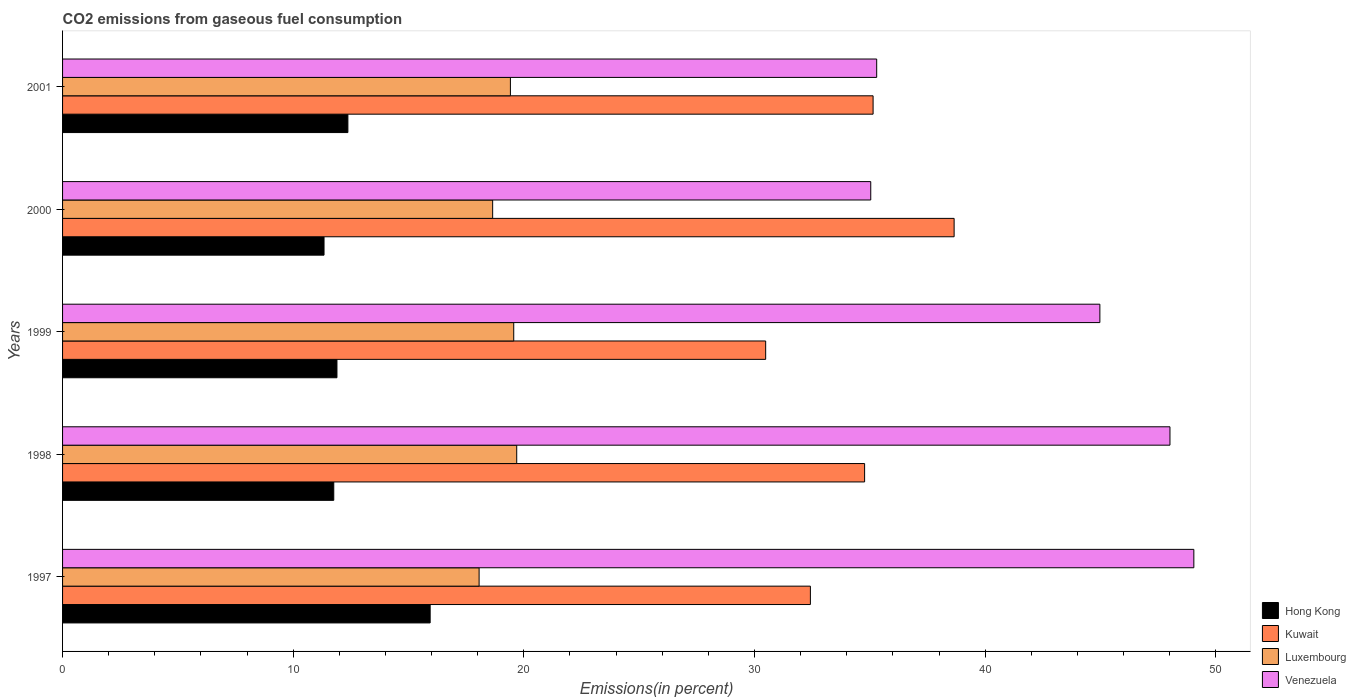What is the label of the 2nd group of bars from the top?
Offer a terse response. 2000. What is the total CO2 emitted in Kuwait in 1999?
Ensure brevity in your answer.  30.48. Across all years, what is the maximum total CO2 emitted in Luxembourg?
Make the answer very short. 19.69. Across all years, what is the minimum total CO2 emitted in Kuwait?
Your answer should be very brief. 30.48. What is the total total CO2 emitted in Venezuela in the graph?
Provide a short and direct response. 212.38. What is the difference between the total CO2 emitted in Venezuela in 1997 and that in 1998?
Your answer should be compact. 1.04. What is the difference between the total CO2 emitted in Venezuela in 2001 and the total CO2 emitted in Kuwait in 1999?
Your answer should be very brief. 4.81. What is the average total CO2 emitted in Kuwait per year?
Ensure brevity in your answer.  34.3. In the year 2000, what is the difference between the total CO2 emitted in Venezuela and total CO2 emitted in Kuwait?
Keep it short and to the point. -3.61. What is the ratio of the total CO2 emitted in Kuwait in 1997 to that in 2000?
Your answer should be compact. 0.84. What is the difference between the highest and the second highest total CO2 emitted in Venezuela?
Your response must be concise. 1.04. What is the difference between the highest and the lowest total CO2 emitted in Kuwait?
Give a very brief answer. 8.17. In how many years, is the total CO2 emitted in Hong Kong greater than the average total CO2 emitted in Hong Kong taken over all years?
Provide a short and direct response. 1. What does the 1st bar from the top in 2001 represents?
Keep it short and to the point. Venezuela. What does the 1st bar from the bottom in 1997 represents?
Your answer should be very brief. Hong Kong. How many bars are there?
Your answer should be compact. 20. What is the difference between two consecutive major ticks on the X-axis?
Make the answer very short. 10. Does the graph contain any zero values?
Give a very brief answer. No. Where does the legend appear in the graph?
Make the answer very short. Bottom right. How are the legend labels stacked?
Your answer should be compact. Vertical. What is the title of the graph?
Keep it short and to the point. CO2 emissions from gaseous fuel consumption. What is the label or title of the X-axis?
Your response must be concise. Emissions(in percent). What is the Emissions(in percent) in Hong Kong in 1997?
Offer a terse response. 15.94. What is the Emissions(in percent) of Kuwait in 1997?
Ensure brevity in your answer.  32.42. What is the Emissions(in percent) of Luxembourg in 1997?
Keep it short and to the point. 18.06. What is the Emissions(in percent) in Venezuela in 1997?
Offer a very short reply. 49.05. What is the Emissions(in percent) of Hong Kong in 1998?
Ensure brevity in your answer.  11.76. What is the Emissions(in percent) of Kuwait in 1998?
Make the answer very short. 34.77. What is the Emissions(in percent) in Luxembourg in 1998?
Provide a short and direct response. 19.69. What is the Emissions(in percent) of Venezuela in 1998?
Your response must be concise. 48.01. What is the Emissions(in percent) in Hong Kong in 1999?
Offer a very short reply. 11.9. What is the Emissions(in percent) in Kuwait in 1999?
Your answer should be compact. 30.48. What is the Emissions(in percent) of Luxembourg in 1999?
Ensure brevity in your answer.  19.56. What is the Emissions(in percent) in Venezuela in 1999?
Make the answer very short. 44.97. What is the Emissions(in percent) in Hong Kong in 2000?
Your answer should be compact. 11.34. What is the Emissions(in percent) of Kuwait in 2000?
Provide a succinct answer. 38.66. What is the Emissions(in percent) of Luxembourg in 2000?
Offer a terse response. 18.65. What is the Emissions(in percent) in Venezuela in 2000?
Ensure brevity in your answer.  35.04. What is the Emissions(in percent) in Hong Kong in 2001?
Offer a terse response. 12.37. What is the Emissions(in percent) of Kuwait in 2001?
Ensure brevity in your answer.  35.14. What is the Emissions(in percent) in Luxembourg in 2001?
Ensure brevity in your answer.  19.42. What is the Emissions(in percent) in Venezuela in 2001?
Your answer should be compact. 35.3. Across all years, what is the maximum Emissions(in percent) in Hong Kong?
Your answer should be compact. 15.94. Across all years, what is the maximum Emissions(in percent) in Kuwait?
Your response must be concise. 38.66. Across all years, what is the maximum Emissions(in percent) in Luxembourg?
Offer a very short reply. 19.69. Across all years, what is the maximum Emissions(in percent) in Venezuela?
Offer a terse response. 49.05. Across all years, what is the minimum Emissions(in percent) of Hong Kong?
Offer a terse response. 11.34. Across all years, what is the minimum Emissions(in percent) in Kuwait?
Make the answer very short. 30.48. Across all years, what is the minimum Emissions(in percent) in Luxembourg?
Provide a short and direct response. 18.06. Across all years, what is the minimum Emissions(in percent) in Venezuela?
Your response must be concise. 35.04. What is the total Emissions(in percent) in Hong Kong in the graph?
Your answer should be very brief. 63.3. What is the total Emissions(in percent) in Kuwait in the graph?
Make the answer very short. 171.48. What is the total Emissions(in percent) of Luxembourg in the graph?
Provide a short and direct response. 95.38. What is the total Emissions(in percent) of Venezuela in the graph?
Give a very brief answer. 212.38. What is the difference between the Emissions(in percent) in Hong Kong in 1997 and that in 1998?
Your answer should be compact. 4.18. What is the difference between the Emissions(in percent) of Kuwait in 1997 and that in 1998?
Ensure brevity in your answer.  -2.35. What is the difference between the Emissions(in percent) of Luxembourg in 1997 and that in 1998?
Ensure brevity in your answer.  -1.63. What is the difference between the Emissions(in percent) of Venezuela in 1997 and that in 1998?
Your response must be concise. 1.04. What is the difference between the Emissions(in percent) of Hong Kong in 1997 and that in 1999?
Provide a short and direct response. 4.04. What is the difference between the Emissions(in percent) of Kuwait in 1997 and that in 1999?
Give a very brief answer. 1.94. What is the difference between the Emissions(in percent) of Luxembourg in 1997 and that in 1999?
Keep it short and to the point. -1.5. What is the difference between the Emissions(in percent) of Venezuela in 1997 and that in 1999?
Keep it short and to the point. 4.07. What is the difference between the Emissions(in percent) in Hong Kong in 1997 and that in 2000?
Offer a very short reply. 4.6. What is the difference between the Emissions(in percent) of Kuwait in 1997 and that in 2000?
Ensure brevity in your answer.  -6.23. What is the difference between the Emissions(in percent) of Luxembourg in 1997 and that in 2000?
Provide a short and direct response. -0.59. What is the difference between the Emissions(in percent) in Venezuela in 1997 and that in 2000?
Give a very brief answer. 14.01. What is the difference between the Emissions(in percent) in Hong Kong in 1997 and that in 2001?
Provide a short and direct response. 3.57. What is the difference between the Emissions(in percent) in Kuwait in 1997 and that in 2001?
Ensure brevity in your answer.  -2.72. What is the difference between the Emissions(in percent) in Luxembourg in 1997 and that in 2001?
Your answer should be compact. -1.36. What is the difference between the Emissions(in percent) in Venezuela in 1997 and that in 2001?
Provide a short and direct response. 13.75. What is the difference between the Emissions(in percent) of Hong Kong in 1998 and that in 1999?
Your response must be concise. -0.14. What is the difference between the Emissions(in percent) of Kuwait in 1998 and that in 1999?
Your response must be concise. 4.29. What is the difference between the Emissions(in percent) in Luxembourg in 1998 and that in 1999?
Make the answer very short. 0.13. What is the difference between the Emissions(in percent) in Venezuela in 1998 and that in 1999?
Offer a very short reply. 3.04. What is the difference between the Emissions(in percent) of Hong Kong in 1998 and that in 2000?
Ensure brevity in your answer.  0.42. What is the difference between the Emissions(in percent) of Kuwait in 1998 and that in 2000?
Keep it short and to the point. -3.88. What is the difference between the Emissions(in percent) of Luxembourg in 1998 and that in 2000?
Provide a short and direct response. 1.04. What is the difference between the Emissions(in percent) of Venezuela in 1998 and that in 2000?
Provide a short and direct response. 12.97. What is the difference between the Emissions(in percent) of Hong Kong in 1998 and that in 2001?
Offer a very short reply. -0.61. What is the difference between the Emissions(in percent) of Kuwait in 1998 and that in 2001?
Your response must be concise. -0.37. What is the difference between the Emissions(in percent) of Luxembourg in 1998 and that in 2001?
Offer a terse response. 0.27. What is the difference between the Emissions(in percent) in Venezuela in 1998 and that in 2001?
Offer a terse response. 12.72. What is the difference between the Emissions(in percent) in Hong Kong in 1999 and that in 2000?
Your answer should be very brief. 0.56. What is the difference between the Emissions(in percent) of Kuwait in 1999 and that in 2000?
Offer a terse response. -8.17. What is the difference between the Emissions(in percent) of Luxembourg in 1999 and that in 2000?
Keep it short and to the point. 0.91. What is the difference between the Emissions(in percent) in Venezuela in 1999 and that in 2000?
Give a very brief answer. 9.93. What is the difference between the Emissions(in percent) of Hong Kong in 1999 and that in 2001?
Keep it short and to the point. -0.47. What is the difference between the Emissions(in percent) in Kuwait in 1999 and that in 2001?
Your answer should be very brief. -4.66. What is the difference between the Emissions(in percent) of Luxembourg in 1999 and that in 2001?
Offer a terse response. 0.14. What is the difference between the Emissions(in percent) in Venezuela in 1999 and that in 2001?
Offer a very short reply. 9.68. What is the difference between the Emissions(in percent) in Hong Kong in 2000 and that in 2001?
Provide a short and direct response. -1.03. What is the difference between the Emissions(in percent) of Kuwait in 2000 and that in 2001?
Offer a terse response. 3.51. What is the difference between the Emissions(in percent) in Luxembourg in 2000 and that in 2001?
Your answer should be compact. -0.77. What is the difference between the Emissions(in percent) of Venezuela in 2000 and that in 2001?
Offer a very short reply. -0.26. What is the difference between the Emissions(in percent) in Hong Kong in 1997 and the Emissions(in percent) in Kuwait in 1998?
Give a very brief answer. -18.84. What is the difference between the Emissions(in percent) in Hong Kong in 1997 and the Emissions(in percent) in Luxembourg in 1998?
Your answer should be compact. -3.75. What is the difference between the Emissions(in percent) in Hong Kong in 1997 and the Emissions(in percent) in Venezuela in 1998?
Give a very brief answer. -32.08. What is the difference between the Emissions(in percent) in Kuwait in 1997 and the Emissions(in percent) in Luxembourg in 1998?
Keep it short and to the point. 12.73. What is the difference between the Emissions(in percent) in Kuwait in 1997 and the Emissions(in percent) in Venezuela in 1998?
Offer a very short reply. -15.59. What is the difference between the Emissions(in percent) of Luxembourg in 1997 and the Emissions(in percent) of Venezuela in 1998?
Make the answer very short. -29.95. What is the difference between the Emissions(in percent) of Hong Kong in 1997 and the Emissions(in percent) of Kuwait in 1999?
Give a very brief answer. -14.55. What is the difference between the Emissions(in percent) in Hong Kong in 1997 and the Emissions(in percent) in Luxembourg in 1999?
Offer a terse response. -3.62. What is the difference between the Emissions(in percent) in Hong Kong in 1997 and the Emissions(in percent) in Venezuela in 1999?
Give a very brief answer. -29.04. What is the difference between the Emissions(in percent) of Kuwait in 1997 and the Emissions(in percent) of Luxembourg in 1999?
Ensure brevity in your answer.  12.86. What is the difference between the Emissions(in percent) in Kuwait in 1997 and the Emissions(in percent) in Venezuela in 1999?
Keep it short and to the point. -12.55. What is the difference between the Emissions(in percent) of Luxembourg in 1997 and the Emissions(in percent) of Venezuela in 1999?
Your answer should be very brief. -26.91. What is the difference between the Emissions(in percent) in Hong Kong in 1997 and the Emissions(in percent) in Kuwait in 2000?
Offer a very short reply. -22.72. What is the difference between the Emissions(in percent) in Hong Kong in 1997 and the Emissions(in percent) in Luxembourg in 2000?
Your response must be concise. -2.71. What is the difference between the Emissions(in percent) in Hong Kong in 1997 and the Emissions(in percent) in Venezuela in 2000?
Keep it short and to the point. -19.1. What is the difference between the Emissions(in percent) of Kuwait in 1997 and the Emissions(in percent) of Luxembourg in 2000?
Provide a short and direct response. 13.78. What is the difference between the Emissions(in percent) in Kuwait in 1997 and the Emissions(in percent) in Venezuela in 2000?
Provide a succinct answer. -2.62. What is the difference between the Emissions(in percent) of Luxembourg in 1997 and the Emissions(in percent) of Venezuela in 2000?
Ensure brevity in your answer.  -16.98. What is the difference between the Emissions(in percent) of Hong Kong in 1997 and the Emissions(in percent) of Kuwait in 2001?
Offer a very short reply. -19.2. What is the difference between the Emissions(in percent) in Hong Kong in 1997 and the Emissions(in percent) in Luxembourg in 2001?
Your answer should be compact. -3.48. What is the difference between the Emissions(in percent) in Hong Kong in 1997 and the Emissions(in percent) in Venezuela in 2001?
Offer a very short reply. -19.36. What is the difference between the Emissions(in percent) of Kuwait in 1997 and the Emissions(in percent) of Luxembourg in 2001?
Your answer should be compact. 13.01. What is the difference between the Emissions(in percent) of Kuwait in 1997 and the Emissions(in percent) of Venezuela in 2001?
Provide a succinct answer. -2.87. What is the difference between the Emissions(in percent) of Luxembourg in 1997 and the Emissions(in percent) of Venezuela in 2001?
Offer a very short reply. -17.24. What is the difference between the Emissions(in percent) in Hong Kong in 1998 and the Emissions(in percent) in Kuwait in 1999?
Ensure brevity in your answer.  -18.73. What is the difference between the Emissions(in percent) of Hong Kong in 1998 and the Emissions(in percent) of Luxembourg in 1999?
Your answer should be very brief. -7.8. What is the difference between the Emissions(in percent) of Hong Kong in 1998 and the Emissions(in percent) of Venezuela in 1999?
Your answer should be very brief. -33.22. What is the difference between the Emissions(in percent) in Kuwait in 1998 and the Emissions(in percent) in Luxembourg in 1999?
Offer a terse response. 15.21. What is the difference between the Emissions(in percent) of Kuwait in 1998 and the Emissions(in percent) of Venezuela in 1999?
Provide a succinct answer. -10.2. What is the difference between the Emissions(in percent) of Luxembourg in 1998 and the Emissions(in percent) of Venezuela in 1999?
Keep it short and to the point. -25.28. What is the difference between the Emissions(in percent) in Hong Kong in 1998 and the Emissions(in percent) in Kuwait in 2000?
Provide a short and direct response. -26.9. What is the difference between the Emissions(in percent) of Hong Kong in 1998 and the Emissions(in percent) of Luxembourg in 2000?
Make the answer very short. -6.89. What is the difference between the Emissions(in percent) in Hong Kong in 1998 and the Emissions(in percent) in Venezuela in 2000?
Give a very brief answer. -23.28. What is the difference between the Emissions(in percent) in Kuwait in 1998 and the Emissions(in percent) in Luxembourg in 2000?
Make the answer very short. 16.13. What is the difference between the Emissions(in percent) of Kuwait in 1998 and the Emissions(in percent) of Venezuela in 2000?
Your response must be concise. -0.27. What is the difference between the Emissions(in percent) of Luxembourg in 1998 and the Emissions(in percent) of Venezuela in 2000?
Make the answer very short. -15.35. What is the difference between the Emissions(in percent) of Hong Kong in 1998 and the Emissions(in percent) of Kuwait in 2001?
Give a very brief answer. -23.38. What is the difference between the Emissions(in percent) in Hong Kong in 1998 and the Emissions(in percent) in Luxembourg in 2001?
Your answer should be very brief. -7.66. What is the difference between the Emissions(in percent) of Hong Kong in 1998 and the Emissions(in percent) of Venezuela in 2001?
Keep it short and to the point. -23.54. What is the difference between the Emissions(in percent) of Kuwait in 1998 and the Emissions(in percent) of Luxembourg in 2001?
Keep it short and to the point. 15.36. What is the difference between the Emissions(in percent) of Kuwait in 1998 and the Emissions(in percent) of Venezuela in 2001?
Your response must be concise. -0.52. What is the difference between the Emissions(in percent) in Luxembourg in 1998 and the Emissions(in percent) in Venezuela in 2001?
Make the answer very short. -15.61. What is the difference between the Emissions(in percent) of Hong Kong in 1999 and the Emissions(in percent) of Kuwait in 2000?
Make the answer very short. -26.76. What is the difference between the Emissions(in percent) in Hong Kong in 1999 and the Emissions(in percent) in Luxembourg in 2000?
Give a very brief answer. -6.75. What is the difference between the Emissions(in percent) in Hong Kong in 1999 and the Emissions(in percent) in Venezuela in 2000?
Provide a succinct answer. -23.14. What is the difference between the Emissions(in percent) of Kuwait in 1999 and the Emissions(in percent) of Luxembourg in 2000?
Provide a succinct answer. 11.84. What is the difference between the Emissions(in percent) in Kuwait in 1999 and the Emissions(in percent) in Venezuela in 2000?
Provide a short and direct response. -4.56. What is the difference between the Emissions(in percent) in Luxembourg in 1999 and the Emissions(in percent) in Venezuela in 2000?
Ensure brevity in your answer.  -15.48. What is the difference between the Emissions(in percent) in Hong Kong in 1999 and the Emissions(in percent) in Kuwait in 2001?
Your answer should be compact. -23.25. What is the difference between the Emissions(in percent) in Hong Kong in 1999 and the Emissions(in percent) in Luxembourg in 2001?
Make the answer very short. -7.52. What is the difference between the Emissions(in percent) of Hong Kong in 1999 and the Emissions(in percent) of Venezuela in 2001?
Provide a succinct answer. -23.4. What is the difference between the Emissions(in percent) in Kuwait in 1999 and the Emissions(in percent) in Luxembourg in 2001?
Ensure brevity in your answer.  11.07. What is the difference between the Emissions(in percent) in Kuwait in 1999 and the Emissions(in percent) in Venezuela in 2001?
Ensure brevity in your answer.  -4.81. What is the difference between the Emissions(in percent) in Luxembourg in 1999 and the Emissions(in percent) in Venezuela in 2001?
Keep it short and to the point. -15.74. What is the difference between the Emissions(in percent) in Hong Kong in 2000 and the Emissions(in percent) in Kuwait in 2001?
Your answer should be compact. -23.81. What is the difference between the Emissions(in percent) in Hong Kong in 2000 and the Emissions(in percent) in Luxembourg in 2001?
Offer a very short reply. -8.08. What is the difference between the Emissions(in percent) of Hong Kong in 2000 and the Emissions(in percent) of Venezuela in 2001?
Offer a very short reply. -23.96. What is the difference between the Emissions(in percent) in Kuwait in 2000 and the Emissions(in percent) in Luxembourg in 2001?
Give a very brief answer. 19.24. What is the difference between the Emissions(in percent) in Kuwait in 2000 and the Emissions(in percent) in Venezuela in 2001?
Keep it short and to the point. 3.36. What is the difference between the Emissions(in percent) in Luxembourg in 2000 and the Emissions(in percent) in Venezuela in 2001?
Ensure brevity in your answer.  -16.65. What is the average Emissions(in percent) of Hong Kong per year?
Make the answer very short. 12.66. What is the average Emissions(in percent) in Kuwait per year?
Keep it short and to the point. 34.3. What is the average Emissions(in percent) in Luxembourg per year?
Provide a short and direct response. 19.08. What is the average Emissions(in percent) of Venezuela per year?
Offer a very short reply. 42.48. In the year 1997, what is the difference between the Emissions(in percent) in Hong Kong and Emissions(in percent) in Kuwait?
Provide a succinct answer. -16.49. In the year 1997, what is the difference between the Emissions(in percent) in Hong Kong and Emissions(in percent) in Luxembourg?
Your response must be concise. -2.12. In the year 1997, what is the difference between the Emissions(in percent) in Hong Kong and Emissions(in percent) in Venezuela?
Offer a terse response. -33.11. In the year 1997, what is the difference between the Emissions(in percent) in Kuwait and Emissions(in percent) in Luxembourg?
Make the answer very short. 14.36. In the year 1997, what is the difference between the Emissions(in percent) of Kuwait and Emissions(in percent) of Venezuela?
Your answer should be compact. -16.63. In the year 1997, what is the difference between the Emissions(in percent) in Luxembourg and Emissions(in percent) in Venezuela?
Offer a terse response. -30.99. In the year 1998, what is the difference between the Emissions(in percent) of Hong Kong and Emissions(in percent) of Kuwait?
Offer a very short reply. -23.02. In the year 1998, what is the difference between the Emissions(in percent) in Hong Kong and Emissions(in percent) in Luxembourg?
Your response must be concise. -7.93. In the year 1998, what is the difference between the Emissions(in percent) in Hong Kong and Emissions(in percent) in Venezuela?
Your answer should be compact. -36.26. In the year 1998, what is the difference between the Emissions(in percent) of Kuwait and Emissions(in percent) of Luxembourg?
Provide a short and direct response. 15.08. In the year 1998, what is the difference between the Emissions(in percent) in Kuwait and Emissions(in percent) in Venezuela?
Your answer should be compact. -13.24. In the year 1998, what is the difference between the Emissions(in percent) of Luxembourg and Emissions(in percent) of Venezuela?
Keep it short and to the point. -28.32. In the year 1999, what is the difference between the Emissions(in percent) of Hong Kong and Emissions(in percent) of Kuwait?
Offer a terse response. -18.59. In the year 1999, what is the difference between the Emissions(in percent) of Hong Kong and Emissions(in percent) of Luxembourg?
Provide a succinct answer. -7.66. In the year 1999, what is the difference between the Emissions(in percent) in Hong Kong and Emissions(in percent) in Venezuela?
Offer a terse response. -33.08. In the year 1999, what is the difference between the Emissions(in percent) in Kuwait and Emissions(in percent) in Luxembourg?
Offer a very short reply. 10.92. In the year 1999, what is the difference between the Emissions(in percent) of Kuwait and Emissions(in percent) of Venezuela?
Your answer should be very brief. -14.49. In the year 1999, what is the difference between the Emissions(in percent) of Luxembourg and Emissions(in percent) of Venezuela?
Your response must be concise. -25.41. In the year 2000, what is the difference between the Emissions(in percent) of Hong Kong and Emissions(in percent) of Kuwait?
Your answer should be very brief. -27.32. In the year 2000, what is the difference between the Emissions(in percent) of Hong Kong and Emissions(in percent) of Luxembourg?
Your answer should be compact. -7.31. In the year 2000, what is the difference between the Emissions(in percent) in Hong Kong and Emissions(in percent) in Venezuela?
Offer a very short reply. -23.7. In the year 2000, what is the difference between the Emissions(in percent) of Kuwait and Emissions(in percent) of Luxembourg?
Keep it short and to the point. 20.01. In the year 2000, what is the difference between the Emissions(in percent) of Kuwait and Emissions(in percent) of Venezuela?
Provide a succinct answer. 3.61. In the year 2000, what is the difference between the Emissions(in percent) of Luxembourg and Emissions(in percent) of Venezuela?
Make the answer very short. -16.39. In the year 2001, what is the difference between the Emissions(in percent) in Hong Kong and Emissions(in percent) in Kuwait?
Give a very brief answer. -22.77. In the year 2001, what is the difference between the Emissions(in percent) in Hong Kong and Emissions(in percent) in Luxembourg?
Offer a terse response. -7.05. In the year 2001, what is the difference between the Emissions(in percent) in Hong Kong and Emissions(in percent) in Venezuela?
Ensure brevity in your answer.  -22.93. In the year 2001, what is the difference between the Emissions(in percent) in Kuwait and Emissions(in percent) in Luxembourg?
Offer a terse response. 15.73. In the year 2001, what is the difference between the Emissions(in percent) of Kuwait and Emissions(in percent) of Venezuela?
Provide a short and direct response. -0.16. In the year 2001, what is the difference between the Emissions(in percent) in Luxembourg and Emissions(in percent) in Venezuela?
Give a very brief answer. -15.88. What is the ratio of the Emissions(in percent) of Hong Kong in 1997 to that in 1998?
Provide a succinct answer. 1.36. What is the ratio of the Emissions(in percent) in Kuwait in 1997 to that in 1998?
Provide a short and direct response. 0.93. What is the ratio of the Emissions(in percent) of Luxembourg in 1997 to that in 1998?
Give a very brief answer. 0.92. What is the ratio of the Emissions(in percent) of Venezuela in 1997 to that in 1998?
Your answer should be compact. 1.02. What is the ratio of the Emissions(in percent) of Hong Kong in 1997 to that in 1999?
Your answer should be compact. 1.34. What is the ratio of the Emissions(in percent) in Kuwait in 1997 to that in 1999?
Provide a short and direct response. 1.06. What is the ratio of the Emissions(in percent) of Luxembourg in 1997 to that in 1999?
Make the answer very short. 0.92. What is the ratio of the Emissions(in percent) in Venezuela in 1997 to that in 1999?
Make the answer very short. 1.09. What is the ratio of the Emissions(in percent) in Hong Kong in 1997 to that in 2000?
Your answer should be compact. 1.41. What is the ratio of the Emissions(in percent) of Kuwait in 1997 to that in 2000?
Your response must be concise. 0.84. What is the ratio of the Emissions(in percent) in Luxembourg in 1997 to that in 2000?
Make the answer very short. 0.97. What is the ratio of the Emissions(in percent) in Venezuela in 1997 to that in 2000?
Keep it short and to the point. 1.4. What is the ratio of the Emissions(in percent) in Hong Kong in 1997 to that in 2001?
Provide a short and direct response. 1.29. What is the ratio of the Emissions(in percent) of Kuwait in 1997 to that in 2001?
Offer a terse response. 0.92. What is the ratio of the Emissions(in percent) in Luxembourg in 1997 to that in 2001?
Your answer should be compact. 0.93. What is the ratio of the Emissions(in percent) of Venezuela in 1997 to that in 2001?
Your response must be concise. 1.39. What is the ratio of the Emissions(in percent) in Hong Kong in 1998 to that in 1999?
Keep it short and to the point. 0.99. What is the ratio of the Emissions(in percent) of Kuwait in 1998 to that in 1999?
Your response must be concise. 1.14. What is the ratio of the Emissions(in percent) in Luxembourg in 1998 to that in 1999?
Make the answer very short. 1.01. What is the ratio of the Emissions(in percent) in Venezuela in 1998 to that in 1999?
Provide a short and direct response. 1.07. What is the ratio of the Emissions(in percent) in Hong Kong in 1998 to that in 2000?
Keep it short and to the point. 1.04. What is the ratio of the Emissions(in percent) in Kuwait in 1998 to that in 2000?
Provide a succinct answer. 0.9. What is the ratio of the Emissions(in percent) of Luxembourg in 1998 to that in 2000?
Provide a short and direct response. 1.06. What is the ratio of the Emissions(in percent) of Venezuela in 1998 to that in 2000?
Your response must be concise. 1.37. What is the ratio of the Emissions(in percent) in Hong Kong in 1998 to that in 2001?
Offer a very short reply. 0.95. What is the ratio of the Emissions(in percent) in Kuwait in 1998 to that in 2001?
Your answer should be very brief. 0.99. What is the ratio of the Emissions(in percent) of Luxembourg in 1998 to that in 2001?
Give a very brief answer. 1.01. What is the ratio of the Emissions(in percent) in Venezuela in 1998 to that in 2001?
Offer a terse response. 1.36. What is the ratio of the Emissions(in percent) of Hong Kong in 1999 to that in 2000?
Ensure brevity in your answer.  1.05. What is the ratio of the Emissions(in percent) of Kuwait in 1999 to that in 2000?
Make the answer very short. 0.79. What is the ratio of the Emissions(in percent) of Luxembourg in 1999 to that in 2000?
Your response must be concise. 1.05. What is the ratio of the Emissions(in percent) in Venezuela in 1999 to that in 2000?
Make the answer very short. 1.28. What is the ratio of the Emissions(in percent) of Hong Kong in 1999 to that in 2001?
Provide a succinct answer. 0.96. What is the ratio of the Emissions(in percent) in Kuwait in 1999 to that in 2001?
Your answer should be very brief. 0.87. What is the ratio of the Emissions(in percent) in Luxembourg in 1999 to that in 2001?
Offer a very short reply. 1.01. What is the ratio of the Emissions(in percent) of Venezuela in 1999 to that in 2001?
Your answer should be compact. 1.27. What is the ratio of the Emissions(in percent) of Hong Kong in 2000 to that in 2001?
Your response must be concise. 0.92. What is the ratio of the Emissions(in percent) of Luxembourg in 2000 to that in 2001?
Your response must be concise. 0.96. What is the ratio of the Emissions(in percent) of Venezuela in 2000 to that in 2001?
Make the answer very short. 0.99. What is the difference between the highest and the second highest Emissions(in percent) in Hong Kong?
Your answer should be compact. 3.57. What is the difference between the highest and the second highest Emissions(in percent) of Kuwait?
Your answer should be compact. 3.51. What is the difference between the highest and the second highest Emissions(in percent) in Luxembourg?
Offer a terse response. 0.13. What is the difference between the highest and the second highest Emissions(in percent) of Venezuela?
Provide a short and direct response. 1.04. What is the difference between the highest and the lowest Emissions(in percent) in Hong Kong?
Make the answer very short. 4.6. What is the difference between the highest and the lowest Emissions(in percent) of Kuwait?
Provide a short and direct response. 8.17. What is the difference between the highest and the lowest Emissions(in percent) of Luxembourg?
Your answer should be compact. 1.63. What is the difference between the highest and the lowest Emissions(in percent) in Venezuela?
Make the answer very short. 14.01. 